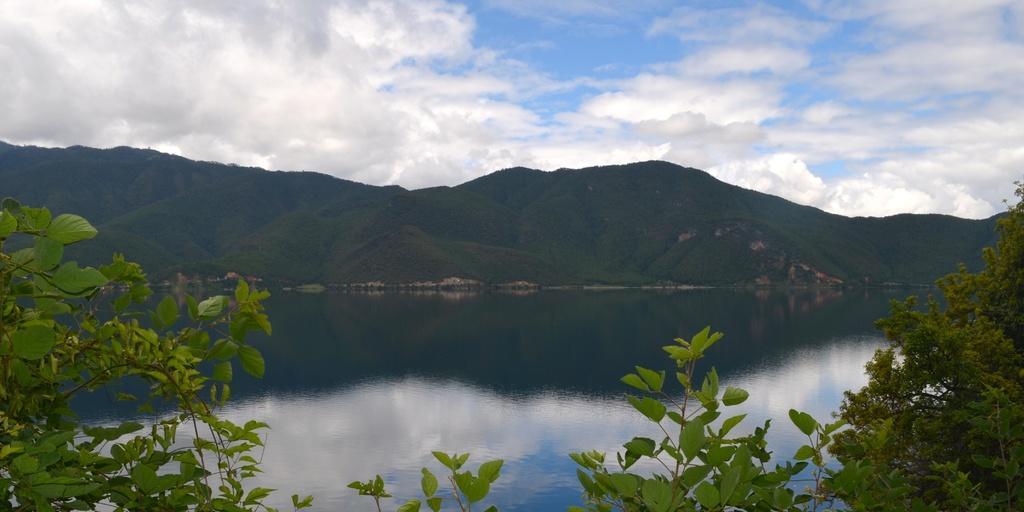Describe this image in one or two sentences. In this image we can see trees, water, hills, sky and clouds. 